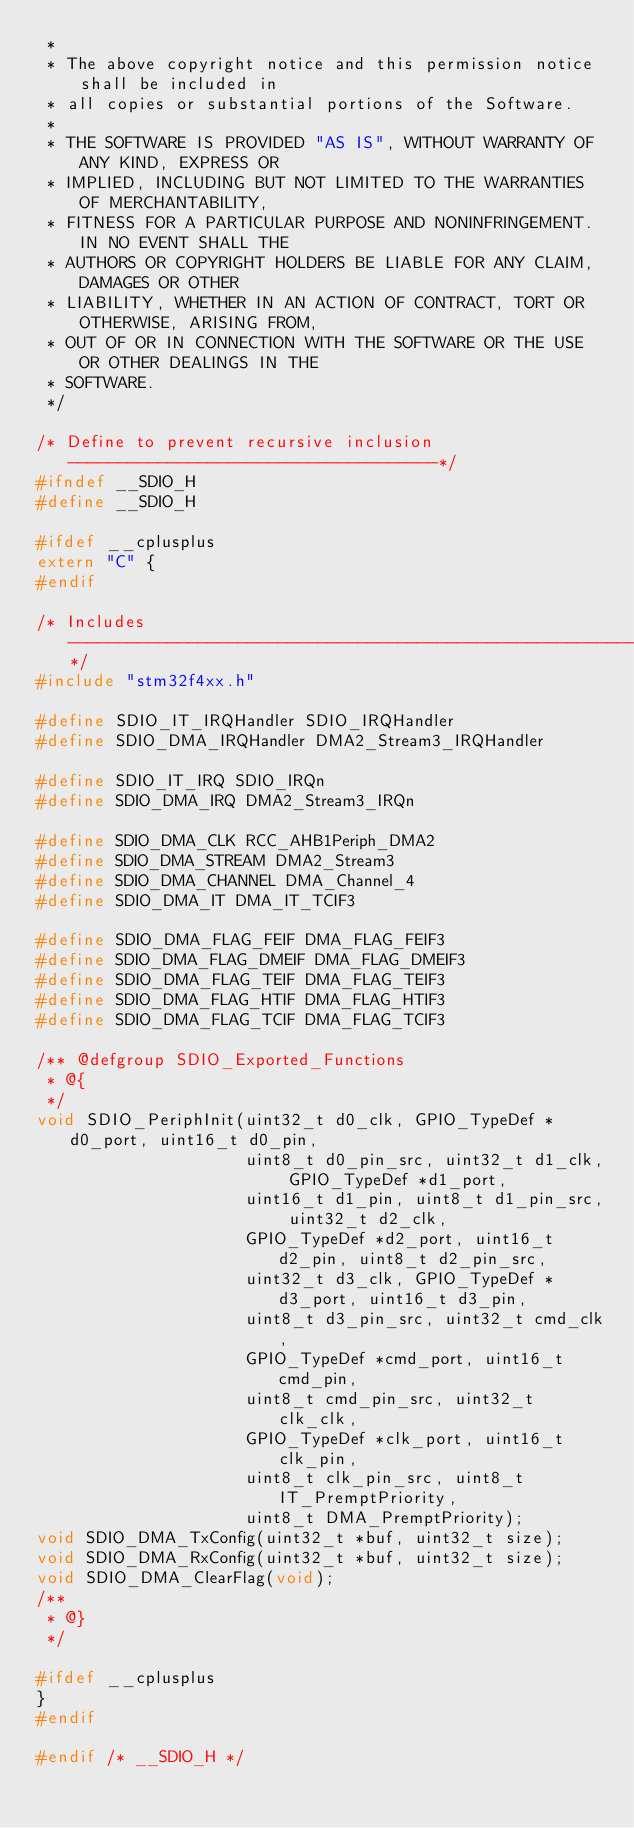<code> <loc_0><loc_0><loc_500><loc_500><_C_> *
 * The above copyright notice and this permission notice shall be included in
 * all copies or substantial portions of the Software.
 *
 * THE SOFTWARE IS PROVIDED "AS IS", WITHOUT WARRANTY OF ANY KIND, EXPRESS OR
 * IMPLIED, INCLUDING BUT NOT LIMITED TO THE WARRANTIES OF MERCHANTABILITY,
 * FITNESS FOR A PARTICULAR PURPOSE AND NONINFRINGEMENT. IN NO EVENT SHALL THE
 * AUTHORS OR COPYRIGHT HOLDERS BE LIABLE FOR ANY CLAIM, DAMAGES OR OTHER
 * LIABILITY, WHETHER IN AN ACTION OF CONTRACT, TORT OR OTHERWISE, ARISING FROM,
 * OUT OF OR IN CONNECTION WITH THE SOFTWARE OR THE USE OR OTHER DEALINGS IN THE
 * SOFTWARE.
 */

/* Define to prevent recursive inclusion -------------------------------------*/
#ifndef __SDIO_H
#define __SDIO_H

#ifdef __cplusplus
extern "C" {
#endif

/* Includes ------------------------------------------------------------------*/
#include "stm32f4xx.h"

#define SDIO_IT_IRQHandler SDIO_IRQHandler
#define SDIO_DMA_IRQHandler DMA2_Stream3_IRQHandler

#define SDIO_IT_IRQ SDIO_IRQn
#define SDIO_DMA_IRQ DMA2_Stream3_IRQn

#define SDIO_DMA_CLK RCC_AHB1Periph_DMA2
#define SDIO_DMA_STREAM DMA2_Stream3
#define SDIO_DMA_CHANNEL DMA_Channel_4
#define SDIO_DMA_IT DMA_IT_TCIF3

#define SDIO_DMA_FLAG_FEIF DMA_FLAG_FEIF3
#define SDIO_DMA_FLAG_DMEIF DMA_FLAG_DMEIF3
#define SDIO_DMA_FLAG_TEIF DMA_FLAG_TEIF3
#define SDIO_DMA_FLAG_HTIF DMA_FLAG_HTIF3
#define SDIO_DMA_FLAG_TCIF DMA_FLAG_TCIF3

/** @defgroup SDIO_Exported_Functions
 * @{
 */
void SDIO_PeriphInit(uint32_t d0_clk, GPIO_TypeDef *d0_port, uint16_t d0_pin,
                     uint8_t d0_pin_src, uint32_t d1_clk, GPIO_TypeDef *d1_port,
                     uint16_t d1_pin, uint8_t d1_pin_src, uint32_t d2_clk,
                     GPIO_TypeDef *d2_port, uint16_t d2_pin, uint8_t d2_pin_src,
                     uint32_t d3_clk, GPIO_TypeDef *d3_port, uint16_t d3_pin,
                     uint8_t d3_pin_src, uint32_t cmd_clk,
                     GPIO_TypeDef *cmd_port, uint16_t cmd_pin,
                     uint8_t cmd_pin_src, uint32_t clk_clk,
                     GPIO_TypeDef *clk_port, uint16_t clk_pin,
                     uint8_t clk_pin_src, uint8_t IT_PremptPriority,
                     uint8_t DMA_PremptPriority);
void SDIO_DMA_TxConfig(uint32_t *buf, uint32_t size);
void SDIO_DMA_RxConfig(uint32_t *buf, uint32_t size);
void SDIO_DMA_ClearFlag(void);
/**
 * @}
 */

#ifdef __cplusplus
}
#endif

#endif /* __SDIO_H */
</code> 